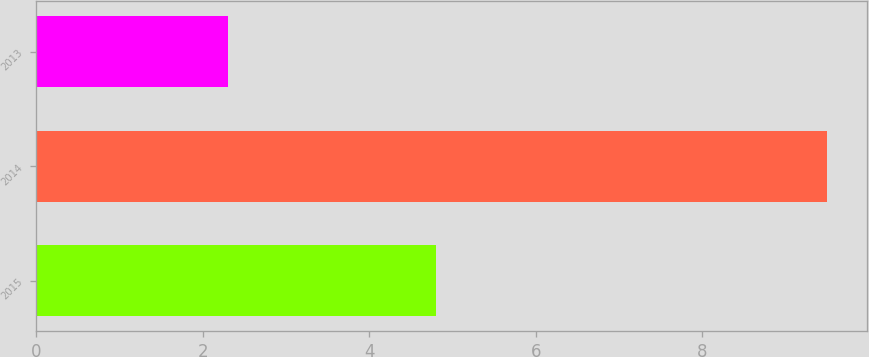Convert chart to OTSL. <chart><loc_0><loc_0><loc_500><loc_500><bar_chart><fcel>2015<fcel>2014<fcel>2013<nl><fcel>4.8<fcel>9.5<fcel>2.3<nl></chart> 